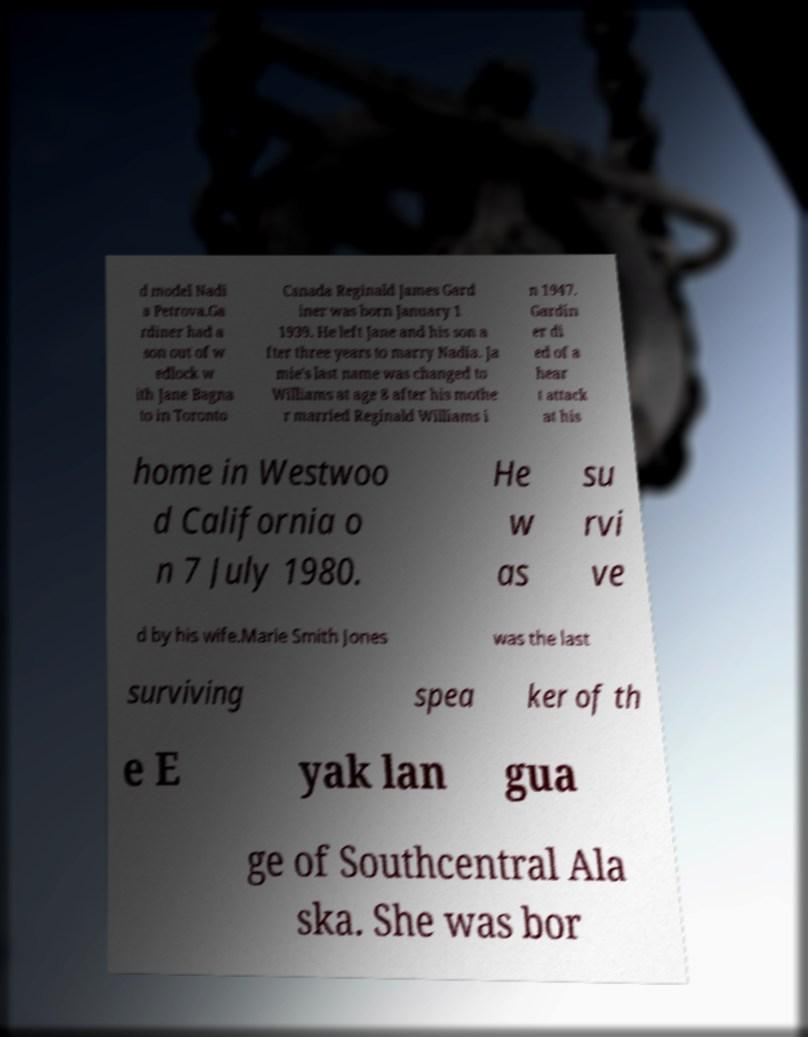Please read and relay the text visible in this image. What does it say? d model Nadi a Petrova.Ga rdiner had a son out of w edlock w ith Jane Bagna to in Toronto Canada Reginald James Gard iner was born January 1 1939. He left Jane and his son a fter three years to marry Nadia. Ja mie's last name was changed to Williams at age 8 after his mothe r married Reginald Williams i n 1947. Gardin er di ed of a hear t attack at his home in Westwoo d California o n 7 July 1980. He w as su rvi ve d by his wife.Marie Smith Jones was the last surviving spea ker of th e E yak lan gua ge of Southcentral Ala ska. She was bor 